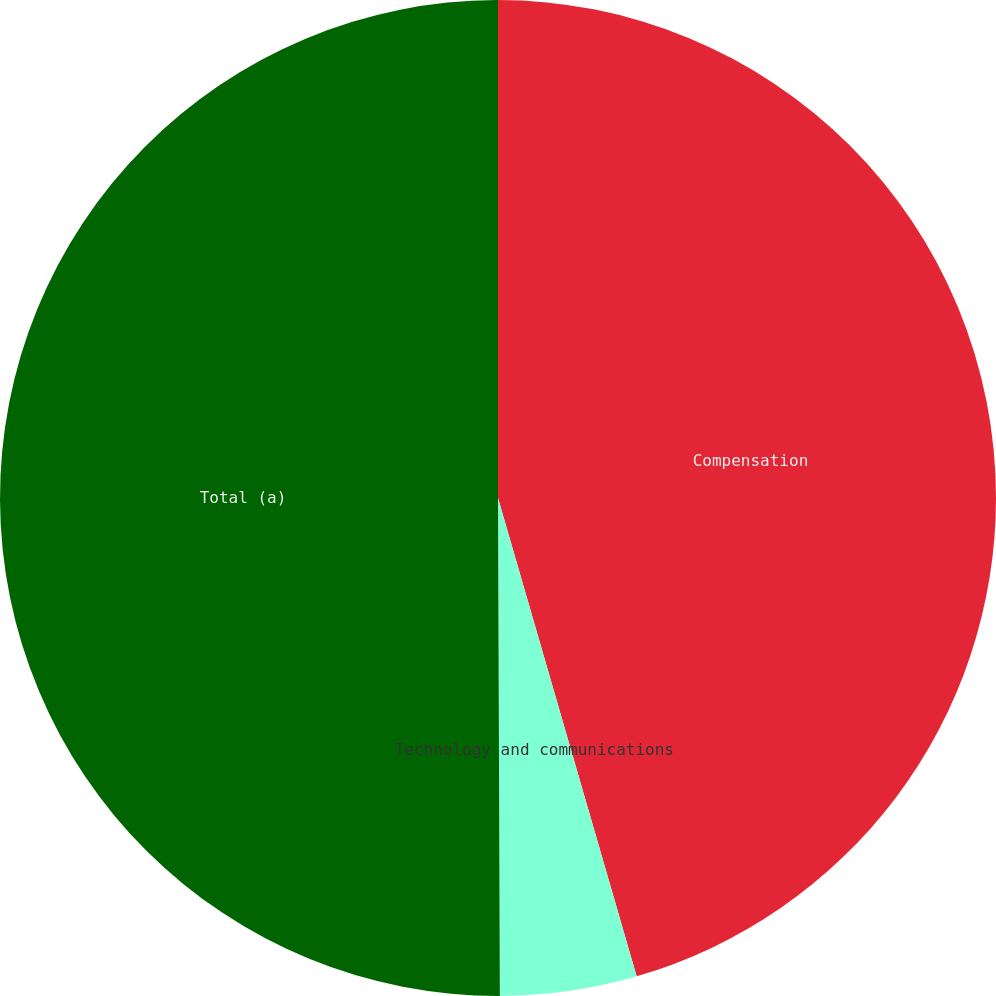Convert chart. <chart><loc_0><loc_0><loc_500><loc_500><pie_chart><fcel>Compensation<fcel>Technology and communications<fcel>Total (a)<nl><fcel>45.51%<fcel>4.43%<fcel>50.06%<nl></chart> 